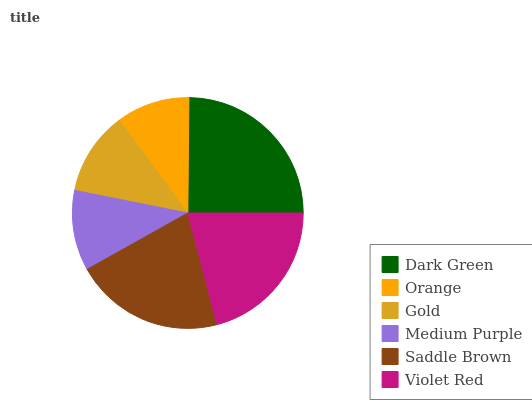Is Orange the minimum?
Answer yes or no. Yes. Is Dark Green the maximum?
Answer yes or no. Yes. Is Gold the minimum?
Answer yes or no. No. Is Gold the maximum?
Answer yes or no. No. Is Gold greater than Orange?
Answer yes or no. Yes. Is Orange less than Gold?
Answer yes or no. Yes. Is Orange greater than Gold?
Answer yes or no. No. Is Gold less than Orange?
Answer yes or no. No. Is Violet Red the high median?
Answer yes or no. Yes. Is Gold the low median?
Answer yes or no. Yes. Is Gold the high median?
Answer yes or no. No. Is Dark Green the low median?
Answer yes or no. No. 